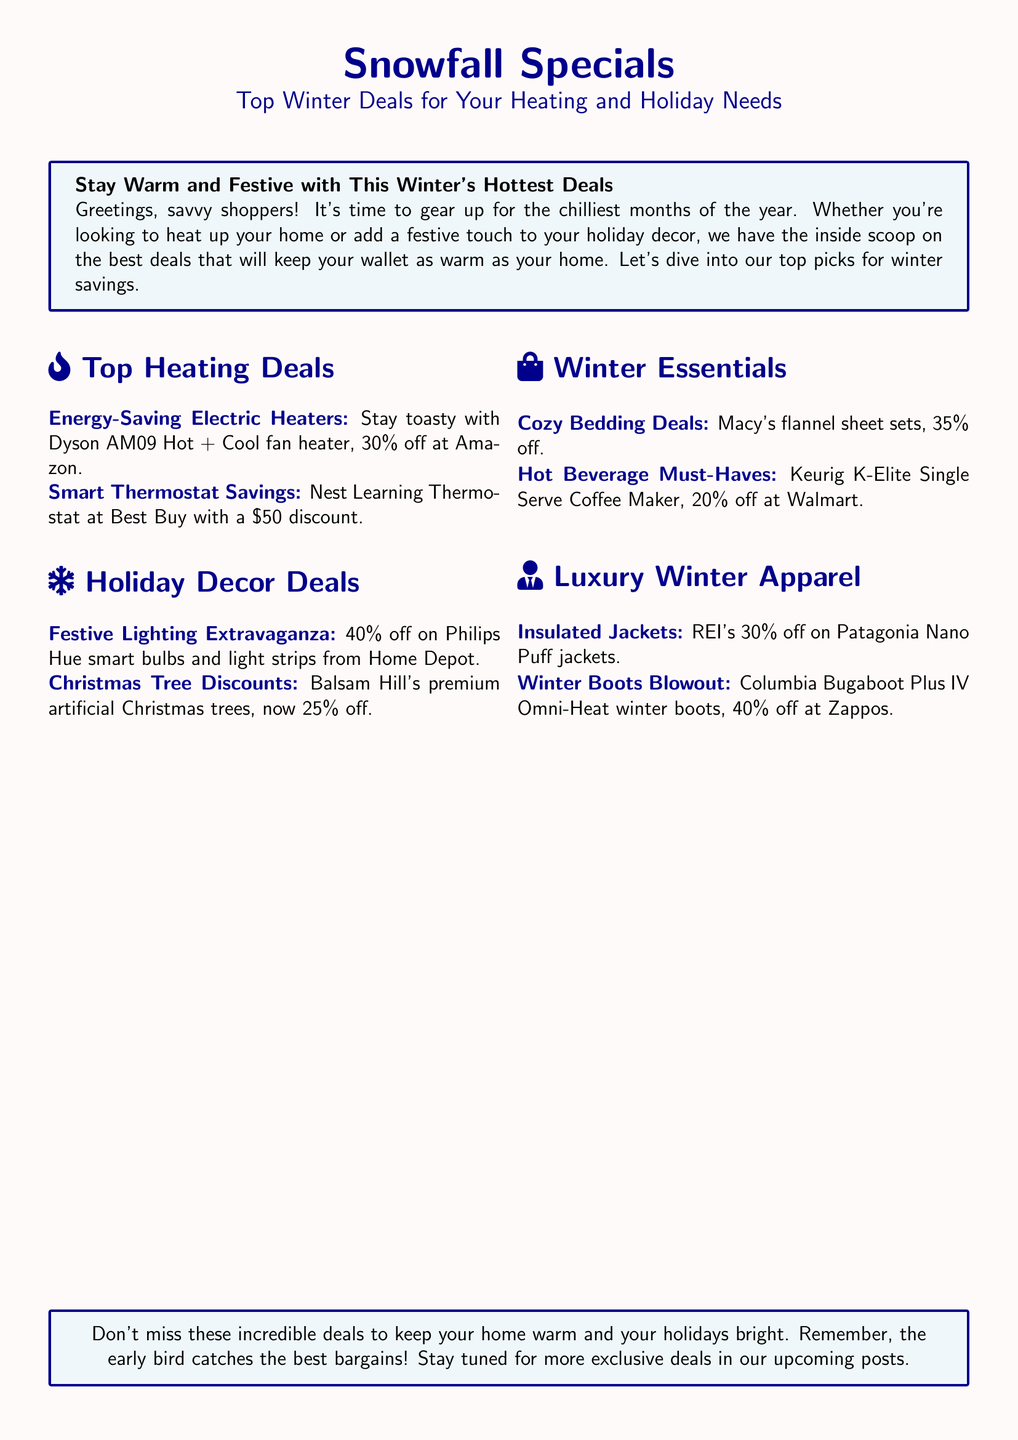What is the discount on Dyson AM09 Hot + Cool fan heater? The document states that the Dyson AM09 Hot + Cool fan heater is 30% off at Amazon.
Answer: 30% off What is the current price reduction on the Nest Learning Thermostat? The Nest Learning Thermostat at Best Buy has a $50 discount.
Answer: $50 What percentage off are Philips Hue smart bulbs? The document mentions a 40% off on Philips Hue smart bulbs from Home Depot.
Answer: 40% What is the discount on Balsam Hill's artificial Christmas trees? Balsam Hill's premium artificial Christmas trees are now 25% off.
Answer: 25% How much discount is offered on Macy's flannel sheet sets? The document notes a discount of 35% off on Macy's flannel sheet sets.
Answer: 35% What is the price reduction for the Keurig K-Elite? The discount on the Keurig K-Elite Single Serve Coffee Maker is 20% off at Walmart.
Answer: 20% Which jacket brand is featured with a discount? The document features Patagonia Nano Puff jackets with a discount.
Answer: Patagonia Nano Puff What is the discount percentage for Columbia winter boots? Columbia Bugaboot Plus IV Omni-Heat winter boots are listed with a discount of 40% off at Zappos.
Answer: 40% What type of products are highlighted under Winter Essentials? The highlighted products under Winter Essentials include cozy bedding and hot beverage must-haves.
Answer: Cozy bedding and hot beverage must-haves 